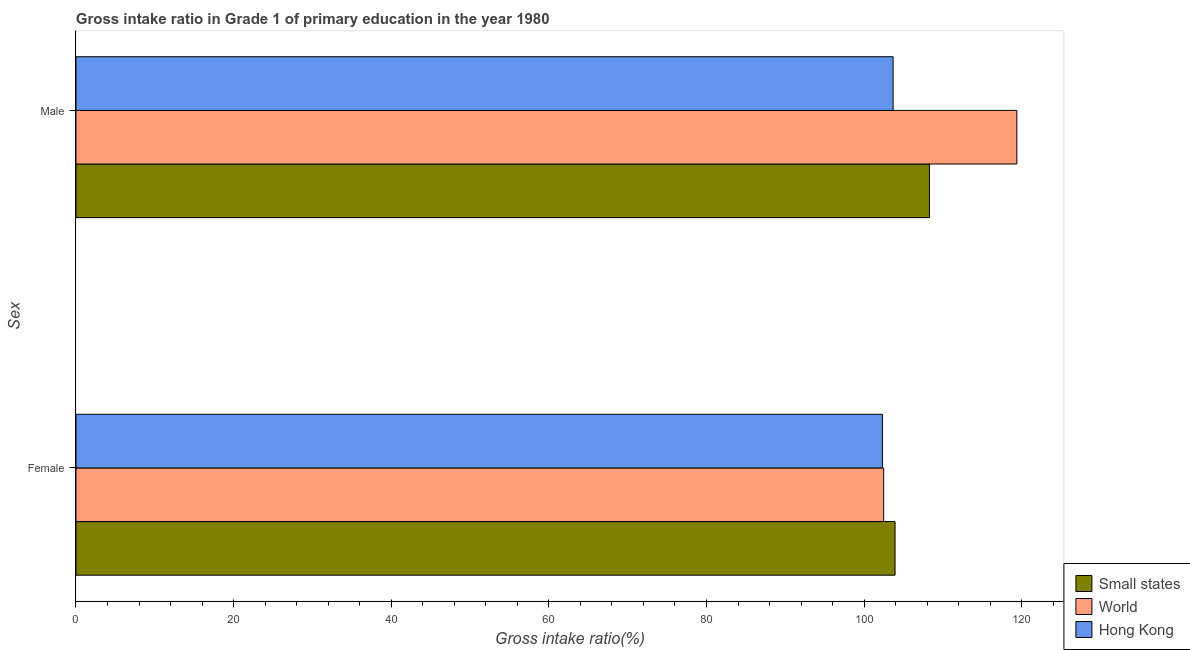How many different coloured bars are there?
Offer a terse response. 3. How many bars are there on the 1st tick from the bottom?
Offer a very short reply. 3. What is the gross intake ratio(female) in World?
Provide a short and direct response. 102.48. Across all countries, what is the maximum gross intake ratio(female)?
Ensure brevity in your answer.  103.93. Across all countries, what is the minimum gross intake ratio(female)?
Make the answer very short. 102.32. In which country was the gross intake ratio(male) minimum?
Your answer should be compact. Hong Kong. What is the total gross intake ratio(male) in the graph?
Provide a succinct answer. 331.35. What is the difference between the gross intake ratio(male) in World and that in Small states?
Your answer should be compact. 11.09. What is the difference between the gross intake ratio(male) in Small states and the gross intake ratio(female) in Hong Kong?
Provide a short and direct response. 5.97. What is the average gross intake ratio(female) per country?
Make the answer very short. 102.91. What is the difference between the gross intake ratio(female) and gross intake ratio(male) in Hong Kong?
Offer a very short reply. -1.36. What is the ratio of the gross intake ratio(male) in Hong Kong to that in Small states?
Provide a short and direct response. 0.96. Is the gross intake ratio(female) in Small states less than that in Hong Kong?
Offer a very short reply. No. In how many countries, is the gross intake ratio(female) greater than the average gross intake ratio(female) taken over all countries?
Provide a short and direct response. 1. What does the 2nd bar from the top in Female represents?
Your answer should be compact. World. How many bars are there?
Make the answer very short. 6. Are all the bars in the graph horizontal?
Your response must be concise. Yes. How many countries are there in the graph?
Provide a succinct answer. 3. Does the graph contain any zero values?
Provide a short and direct response. No. Does the graph contain grids?
Give a very brief answer. No. How are the legend labels stacked?
Keep it short and to the point. Vertical. What is the title of the graph?
Your answer should be compact. Gross intake ratio in Grade 1 of primary education in the year 1980. Does "Luxembourg" appear as one of the legend labels in the graph?
Provide a succinct answer. No. What is the label or title of the X-axis?
Keep it short and to the point. Gross intake ratio(%). What is the label or title of the Y-axis?
Make the answer very short. Sex. What is the Gross intake ratio(%) in Small states in Female?
Ensure brevity in your answer.  103.93. What is the Gross intake ratio(%) in World in Female?
Provide a short and direct response. 102.48. What is the Gross intake ratio(%) in Hong Kong in Female?
Offer a terse response. 102.32. What is the Gross intake ratio(%) of Small states in Male?
Your response must be concise. 108.29. What is the Gross intake ratio(%) in World in Male?
Your response must be concise. 119.38. What is the Gross intake ratio(%) of Hong Kong in Male?
Provide a short and direct response. 103.68. Across all Sex, what is the maximum Gross intake ratio(%) of Small states?
Provide a succinct answer. 108.29. Across all Sex, what is the maximum Gross intake ratio(%) of World?
Provide a short and direct response. 119.38. Across all Sex, what is the maximum Gross intake ratio(%) of Hong Kong?
Ensure brevity in your answer.  103.68. Across all Sex, what is the minimum Gross intake ratio(%) in Small states?
Offer a terse response. 103.93. Across all Sex, what is the minimum Gross intake ratio(%) of World?
Provide a succinct answer. 102.48. Across all Sex, what is the minimum Gross intake ratio(%) in Hong Kong?
Ensure brevity in your answer.  102.32. What is the total Gross intake ratio(%) in Small states in the graph?
Your answer should be compact. 212.22. What is the total Gross intake ratio(%) in World in the graph?
Offer a terse response. 221.85. What is the total Gross intake ratio(%) in Hong Kong in the graph?
Your answer should be very brief. 206. What is the difference between the Gross intake ratio(%) in Small states in Female and that in Male?
Your response must be concise. -4.37. What is the difference between the Gross intake ratio(%) in World in Female and that in Male?
Provide a short and direct response. -16.9. What is the difference between the Gross intake ratio(%) in Hong Kong in Female and that in Male?
Your answer should be compact. -1.36. What is the difference between the Gross intake ratio(%) of Small states in Female and the Gross intake ratio(%) of World in Male?
Your answer should be very brief. -15.45. What is the difference between the Gross intake ratio(%) of Small states in Female and the Gross intake ratio(%) of Hong Kong in Male?
Provide a short and direct response. 0.25. What is the difference between the Gross intake ratio(%) of World in Female and the Gross intake ratio(%) of Hong Kong in Male?
Make the answer very short. -1.2. What is the average Gross intake ratio(%) in Small states per Sex?
Offer a very short reply. 106.11. What is the average Gross intake ratio(%) in World per Sex?
Ensure brevity in your answer.  110.93. What is the average Gross intake ratio(%) in Hong Kong per Sex?
Give a very brief answer. 103. What is the difference between the Gross intake ratio(%) in Small states and Gross intake ratio(%) in World in Female?
Your response must be concise. 1.45. What is the difference between the Gross intake ratio(%) of Small states and Gross intake ratio(%) of Hong Kong in Female?
Ensure brevity in your answer.  1.6. What is the difference between the Gross intake ratio(%) of World and Gross intake ratio(%) of Hong Kong in Female?
Your response must be concise. 0.15. What is the difference between the Gross intake ratio(%) of Small states and Gross intake ratio(%) of World in Male?
Offer a terse response. -11.09. What is the difference between the Gross intake ratio(%) in Small states and Gross intake ratio(%) in Hong Kong in Male?
Keep it short and to the point. 4.62. What is the difference between the Gross intake ratio(%) of World and Gross intake ratio(%) of Hong Kong in Male?
Offer a very short reply. 15.7. What is the ratio of the Gross intake ratio(%) of Small states in Female to that in Male?
Your answer should be compact. 0.96. What is the ratio of the Gross intake ratio(%) in World in Female to that in Male?
Offer a terse response. 0.86. What is the ratio of the Gross intake ratio(%) in Hong Kong in Female to that in Male?
Your answer should be very brief. 0.99. What is the difference between the highest and the second highest Gross intake ratio(%) of Small states?
Make the answer very short. 4.37. What is the difference between the highest and the second highest Gross intake ratio(%) in World?
Give a very brief answer. 16.9. What is the difference between the highest and the second highest Gross intake ratio(%) in Hong Kong?
Your answer should be compact. 1.36. What is the difference between the highest and the lowest Gross intake ratio(%) in Small states?
Your response must be concise. 4.37. What is the difference between the highest and the lowest Gross intake ratio(%) of World?
Offer a terse response. 16.9. What is the difference between the highest and the lowest Gross intake ratio(%) of Hong Kong?
Keep it short and to the point. 1.36. 